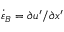<formula> <loc_0><loc_0><loc_500><loc_500>\dot { \varepsilon } _ { B } = \partial u ^ { \prime } / \partial x ^ { \prime }</formula> 